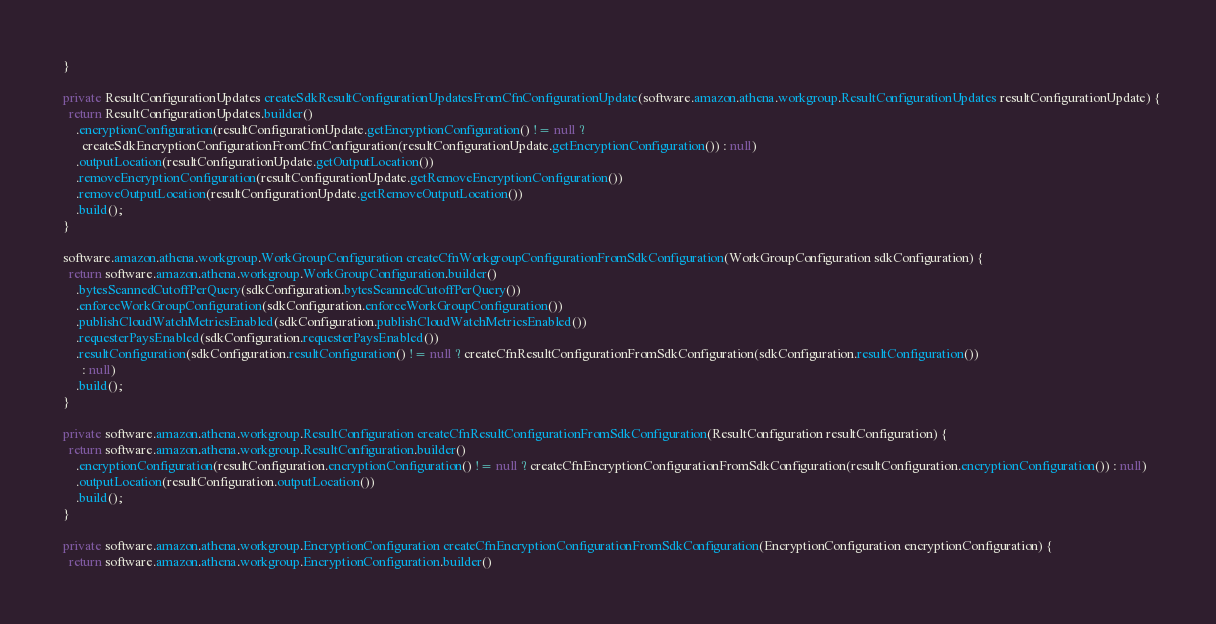Convert code to text. <code><loc_0><loc_0><loc_500><loc_500><_Java_>  }

  private ResultConfigurationUpdates createSdkResultConfigurationUpdatesFromCfnConfigurationUpdate(software.amazon.athena.workgroup.ResultConfigurationUpdates resultConfigurationUpdate) {
    return ResultConfigurationUpdates.builder()
      .encryptionConfiguration(resultConfigurationUpdate.getEncryptionConfiguration() != null ?
        createSdkEncryptionConfigurationFromCfnConfiguration(resultConfigurationUpdate.getEncryptionConfiguration()) : null)
      .outputLocation(resultConfigurationUpdate.getOutputLocation())
      .removeEncryptionConfiguration(resultConfigurationUpdate.getRemoveEncryptionConfiguration())
      .removeOutputLocation(resultConfigurationUpdate.getRemoveOutputLocation())
      .build();
  }

  software.amazon.athena.workgroup.WorkGroupConfiguration createCfnWorkgroupConfigurationFromSdkConfiguration(WorkGroupConfiguration sdkConfiguration) {
    return software.amazon.athena.workgroup.WorkGroupConfiguration.builder()
      .bytesScannedCutoffPerQuery(sdkConfiguration.bytesScannedCutoffPerQuery())
      .enforceWorkGroupConfiguration(sdkConfiguration.enforceWorkGroupConfiguration())
      .publishCloudWatchMetricsEnabled(sdkConfiguration.publishCloudWatchMetricsEnabled())
      .requesterPaysEnabled(sdkConfiguration.requesterPaysEnabled())
      .resultConfiguration(sdkConfiguration.resultConfiguration() != null ? createCfnResultConfigurationFromSdkConfiguration(sdkConfiguration.resultConfiguration())
        : null)
      .build();
  }

  private software.amazon.athena.workgroup.ResultConfiguration createCfnResultConfigurationFromSdkConfiguration(ResultConfiguration resultConfiguration) {
    return software.amazon.athena.workgroup.ResultConfiguration.builder()
      .encryptionConfiguration(resultConfiguration.encryptionConfiguration() != null ? createCfnEncryptionConfigurationFromSdkConfiguration(resultConfiguration.encryptionConfiguration()) : null)
      .outputLocation(resultConfiguration.outputLocation())
      .build();
  }

  private software.amazon.athena.workgroup.EncryptionConfiguration createCfnEncryptionConfigurationFromSdkConfiguration(EncryptionConfiguration encryptionConfiguration) {
    return software.amazon.athena.workgroup.EncryptionConfiguration.builder()</code> 